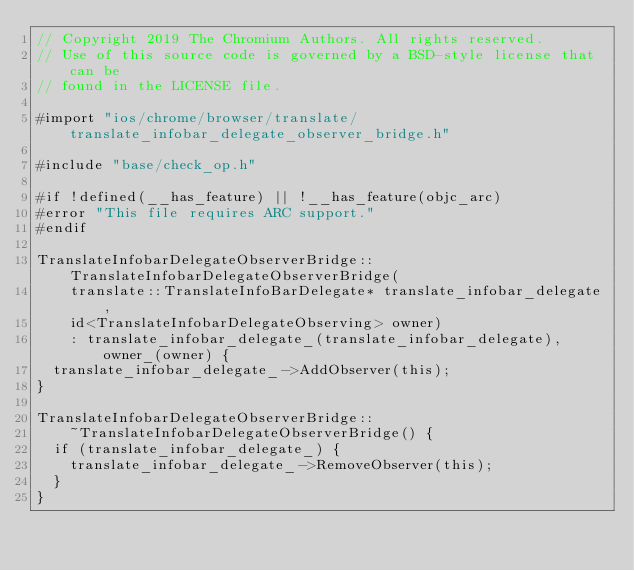<code> <loc_0><loc_0><loc_500><loc_500><_ObjectiveC_>// Copyright 2019 The Chromium Authors. All rights reserved.
// Use of this source code is governed by a BSD-style license that can be
// found in the LICENSE file.

#import "ios/chrome/browser/translate/translate_infobar_delegate_observer_bridge.h"

#include "base/check_op.h"

#if !defined(__has_feature) || !__has_feature(objc_arc)
#error "This file requires ARC support."
#endif

TranslateInfobarDelegateObserverBridge::TranslateInfobarDelegateObserverBridge(
    translate::TranslateInfoBarDelegate* translate_infobar_delegate,
    id<TranslateInfobarDelegateObserving> owner)
    : translate_infobar_delegate_(translate_infobar_delegate), owner_(owner) {
  translate_infobar_delegate_->AddObserver(this);
}

TranslateInfobarDelegateObserverBridge::
    ~TranslateInfobarDelegateObserverBridge() {
  if (translate_infobar_delegate_) {
    translate_infobar_delegate_->RemoveObserver(this);
  }
}
</code> 